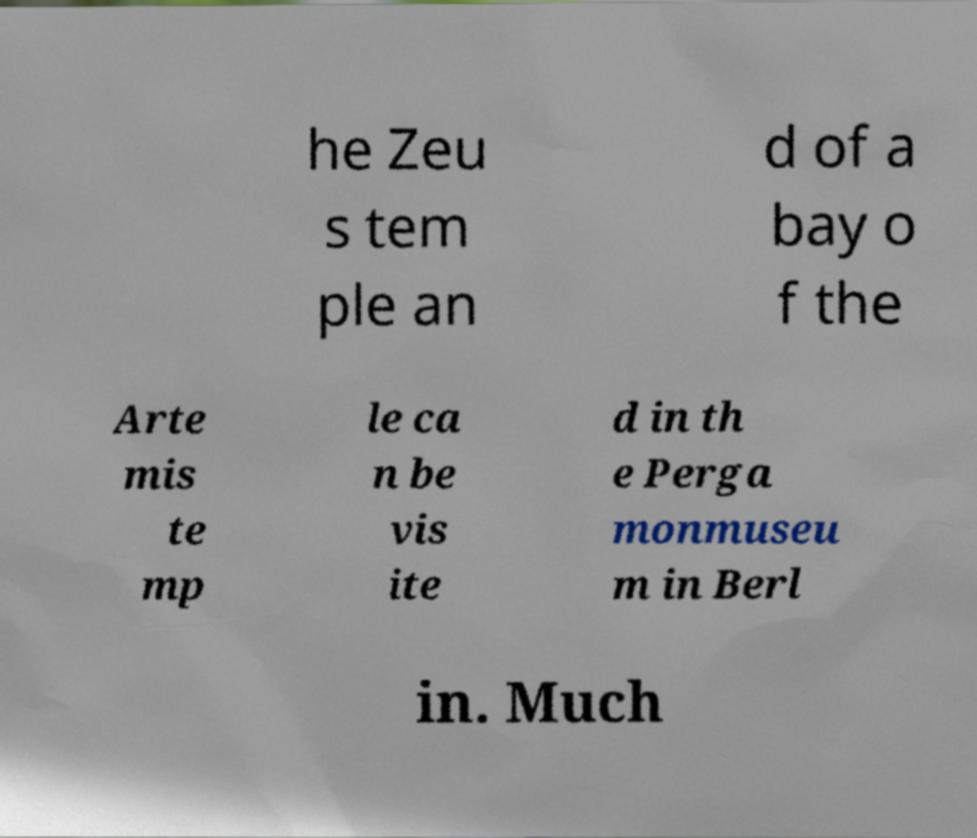I need the written content from this picture converted into text. Can you do that? he Zeu s tem ple an d of a bay o f the Arte mis te mp le ca n be vis ite d in th e Perga monmuseu m in Berl in. Much 